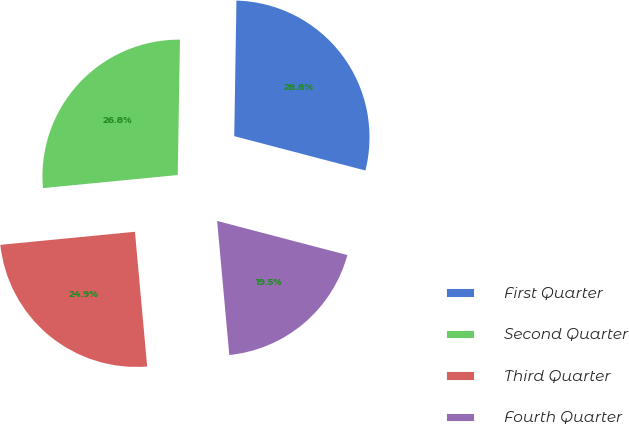<chart> <loc_0><loc_0><loc_500><loc_500><pie_chart><fcel>First Quarter<fcel>Second Quarter<fcel>Third Quarter<fcel>Fourth Quarter<nl><fcel>28.82%<fcel>26.8%<fcel>24.9%<fcel>19.48%<nl></chart> 